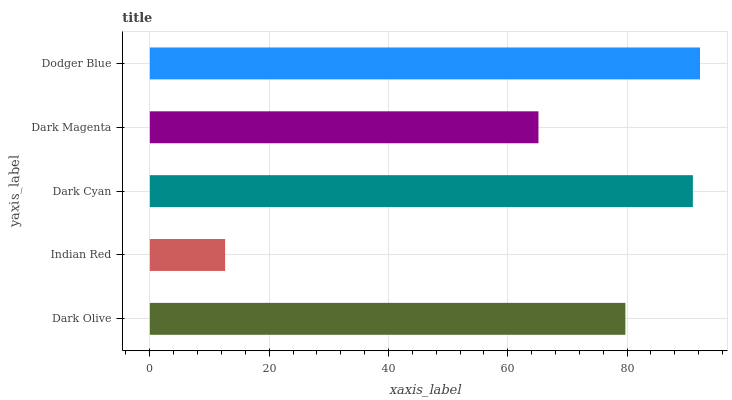Is Indian Red the minimum?
Answer yes or no. Yes. Is Dodger Blue the maximum?
Answer yes or no. Yes. Is Dark Cyan the minimum?
Answer yes or no. No. Is Dark Cyan the maximum?
Answer yes or no. No. Is Dark Cyan greater than Indian Red?
Answer yes or no. Yes. Is Indian Red less than Dark Cyan?
Answer yes or no. Yes. Is Indian Red greater than Dark Cyan?
Answer yes or no. No. Is Dark Cyan less than Indian Red?
Answer yes or no. No. Is Dark Olive the high median?
Answer yes or no. Yes. Is Dark Olive the low median?
Answer yes or no. Yes. Is Indian Red the high median?
Answer yes or no. No. Is Indian Red the low median?
Answer yes or no. No. 